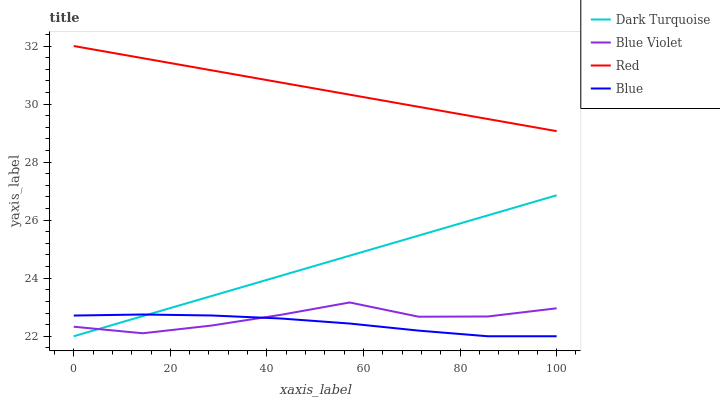Does Blue have the minimum area under the curve?
Answer yes or no. Yes. Does Red have the maximum area under the curve?
Answer yes or no. Yes. Does Dark Turquoise have the minimum area under the curve?
Answer yes or no. No. Does Dark Turquoise have the maximum area under the curve?
Answer yes or no. No. Is Red the smoothest?
Answer yes or no. Yes. Is Blue Violet the roughest?
Answer yes or no. Yes. Is Dark Turquoise the smoothest?
Answer yes or no. No. Is Dark Turquoise the roughest?
Answer yes or no. No. Does Blue have the lowest value?
Answer yes or no. Yes. Does Red have the lowest value?
Answer yes or no. No. Does Red have the highest value?
Answer yes or no. Yes. Does Dark Turquoise have the highest value?
Answer yes or no. No. Is Blue Violet less than Red?
Answer yes or no. Yes. Is Red greater than Blue?
Answer yes or no. Yes. Does Blue intersect Dark Turquoise?
Answer yes or no. Yes. Is Blue less than Dark Turquoise?
Answer yes or no. No. Is Blue greater than Dark Turquoise?
Answer yes or no. No. Does Blue Violet intersect Red?
Answer yes or no. No. 